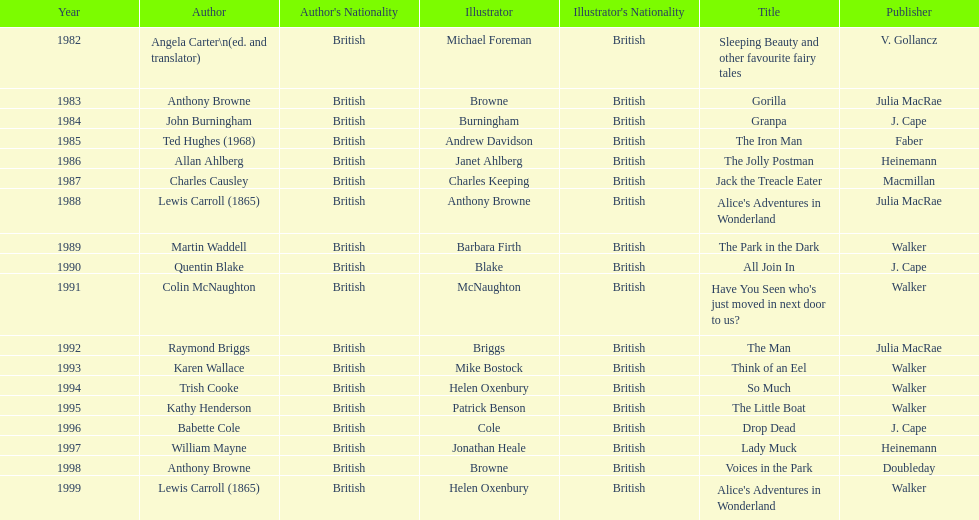How many titles did walker publish? 6. Write the full table. {'header': ['Year', 'Author', "Author's Nationality", 'Illustrator', "Illustrator's Nationality", 'Title', 'Publisher'], 'rows': [['1982', 'Angela Carter\\n(ed. and translator)', 'British', 'Michael Foreman', 'British', 'Sleeping Beauty and other favourite fairy tales', 'V. Gollancz'], ['1983', 'Anthony Browne', 'British', 'Browne', 'British', 'Gorilla', 'Julia MacRae'], ['1984', 'John Burningham', 'British', 'Burningham', 'British', 'Granpa', 'J. Cape'], ['1985', 'Ted Hughes (1968)', 'British', 'Andrew Davidson', 'British', 'The Iron Man', 'Faber'], ['1986', 'Allan Ahlberg', 'British', 'Janet Ahlberg', 'British', 'The Jolly Postman', 'Heinemann'], ['1987', 'Charles Causley', 'British', 'Charles Keeping', 'British', 'Jack the Treacle Eater', 'Macmillan'], ['1988', 'Lewis Carroll (1865)', 'British', 'Anthony Browne', 'British', "Alice's Adventures in Wonderland", 'Julia MacRae'], ['1989', 'Martin Waddell', 'British', 'Barbara Firth', 'British', 'The Park in the Dark', 'Walker'], ['1990', 'Quentin Blake', 'British', 'Blake', 'British', 'All Join In', 'J. Cape'], ['1991', 'Colin McNaughton', 'British', 'McNaughton', 'British', "Have You Seen who's just moved in next door to us?", 'Walker'], ['1992', 'Raymond Briggs', 'British', 'Briggs', 'British', 'The Man', 'Julia MacRae'], ['1993', 'Karen Wallace', 'British', 'Mike Bostock', 'British', 'Think of an Eel', 'Walker'], ['1994', 'Trish Cooke', 'British', 'Helen Oxenbury', 'British', 'So Much', 'Walker'], ['1995', 'Kathy Henderson', 'British', 'Patrick Benson', 'British', 'The Little Boat', 'Walker'], ['1996', 'Babette Cole', 'British', 'Cole', 'British', 'Drop Dead', 'J. Cape'], ['1997', 'William Mayne', 'British', 'Jonathan Heale', 'British', 'Lady Muck', 'Heinemann'], ['1998', 'Anthony Browne', 'British', 'Browne', 'British', 'Voices in the Park', 'Doubleday'], ['1999', 'Lewis Carroll (1865)', 'British', 'Helen Oxenbury', 'British', "Alice's Adventures in Wonderland", 'Walker']]} 